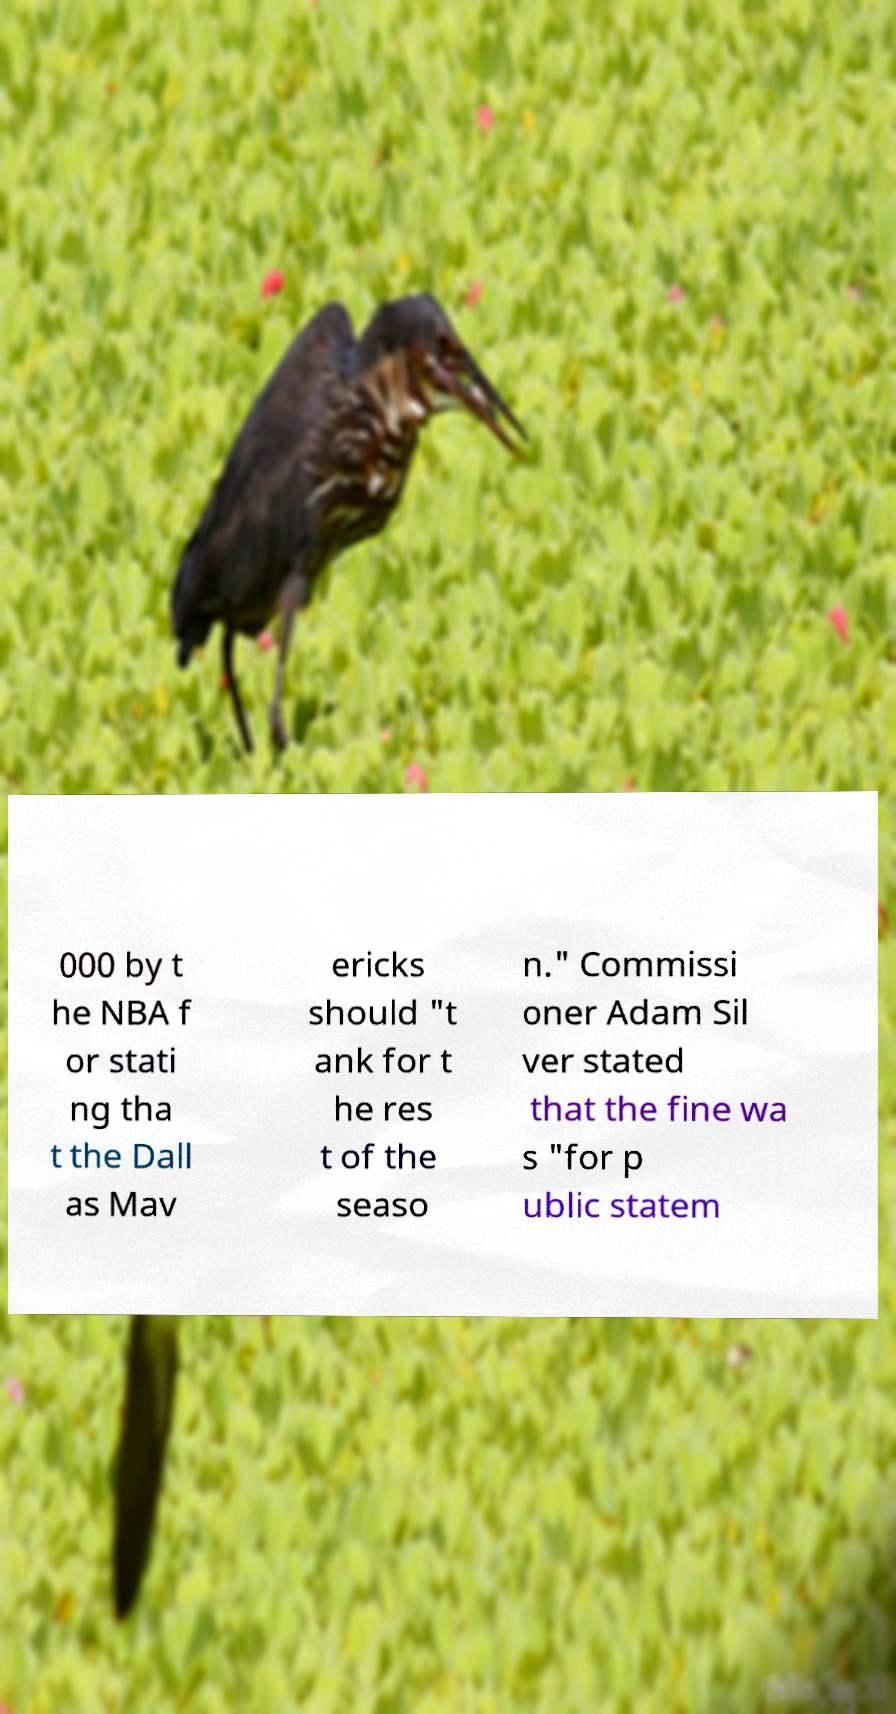I need the written content from this picture converted into text. Can you do that? 000 by t he NBA f or stati ng tha t the Dall as Mav ericks should "t ank for t he res t of the seaso n." Commissi oner Adam Sil ver stated that the fine wa s "for p ublic statem 